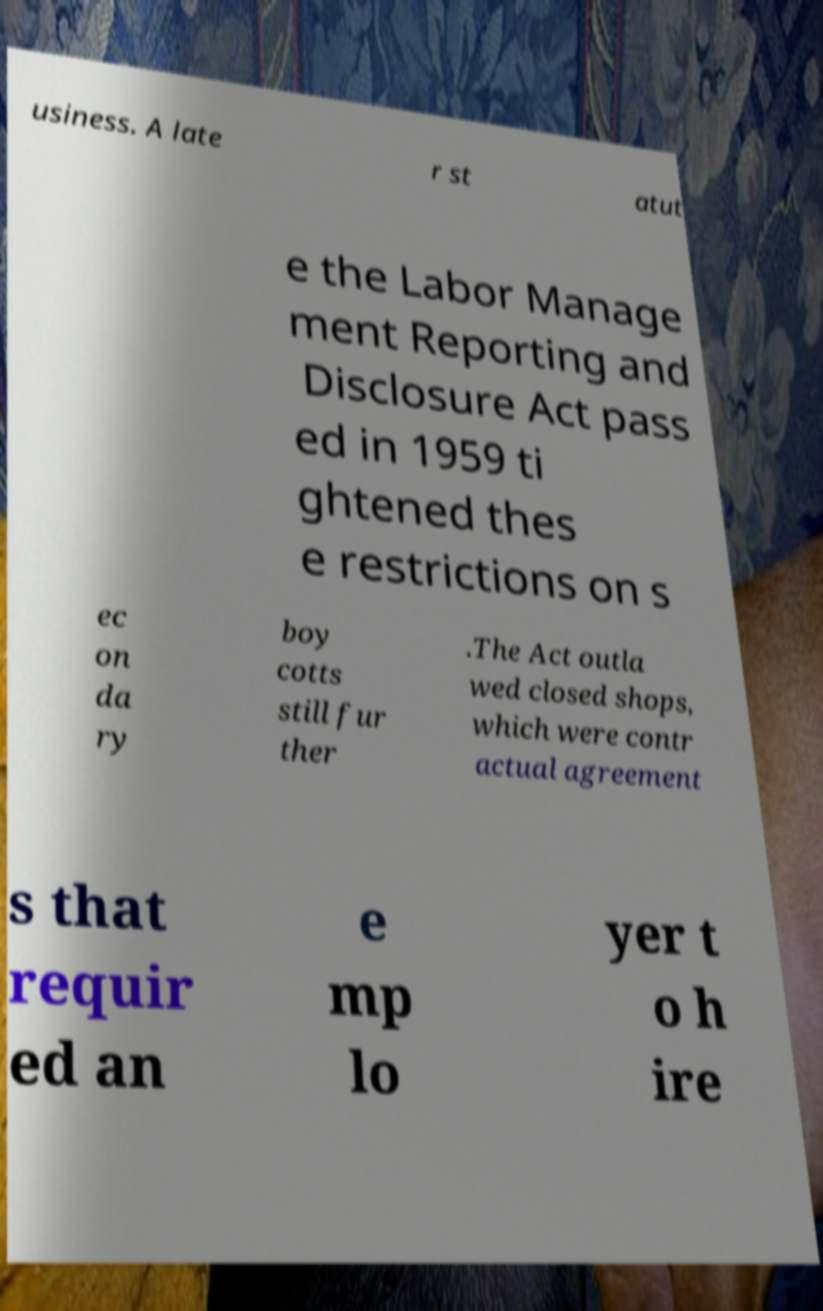Please read and relay the text visible in this image. What does it say? usiness. A late r st atut e the Labor Manage ment Reporting and Disclosure Act pass ed in 1959 ti ghtened thes e restrictions on s ec on da ry boy cotts still fur ther .The Act outla wed closed shops, which were contr actual agreement s that requir ed an e mp lo yer t o h ire 